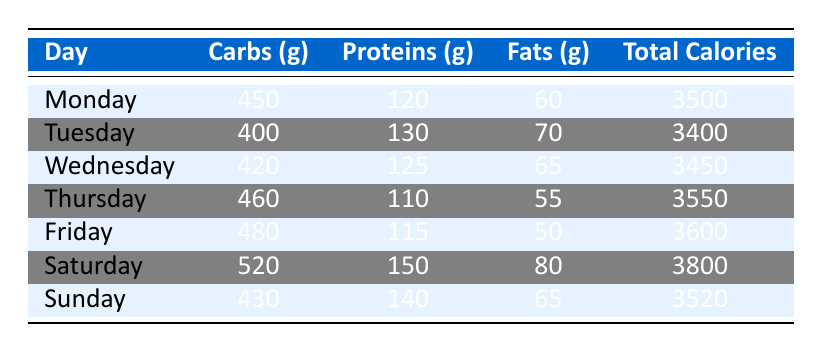What is the total calorie intake for Saturday? The total calorie intake for Saturday is listed in the table under the "Total Calories" column for that day. It states 3800 calories for Saturday.
Answer: 3800 Which day has the highest protein intake? By reviewing the "Proteins (g)" column, I can see that Saturday has the highest protein intake with 150 grams, compared to other days.
Answer: Saturday What is the average amount of carbohydrates consumed throughout the week? To find the average carbohydrates, I sum the carbohydrate intake for the week (450 + 400 + 420 + 460 + 480 + 520 + 430) which equals 3160 grams. There are 7 days, so the average is 3160/7 ≈ 451.43 grams.
Answer: Approximately 451.43 Did Tuesday have a higher total calorie intake than Monday? Looking at the "Total Calories" column, Monday has 3500 calories, while Tuesday has 3400 calories, so it is clear that Tuesday's intake is lower than Monday's.
Answer: No On which day was the fat intake closest to 60 grams? By checking the "Fats (g)" column, Monday has 60 grams, while Wednesday has 65 grams and Thursday has 55 grams. Hence, Monday is the closest with exactly 60 grams.
Answer: Monday Which day had the largest difference in carbohydrate intake compared to the previous day? To find the largest difference, I check the "Carbs (g)" column: Monday to Tuesday (450 - 400 = 50), Tuesday to Wednesday (400 - 420 = 20), and so on. The largest difference is between Friday (480 g) and Saturday (520 g), which is a difference of 40 grams.
Answer: Friday to Saturday What is the total amount of fats consumed on Sunday and Thursday combined? I retrieve the fat intake from both days: Sunday has 65 grams and Thursday has 55 grams. Adding these gives 65 + 55 = 120 grams.
Answer: 120 Which day had the least carbohydrates compared to the others? By analyzing the "Carbs (g)" column, Tuesday shows the least carbohydrate intake at 400 grams, which is lower than all other days.
Answer: Tuesday What is the difference in total calorie intake between Friday and Sunday? The total calories for Friday is 3600 and for Sunday is 3520. So the difference is 3600 - 3520 = 80 calories.
Answer: 80 